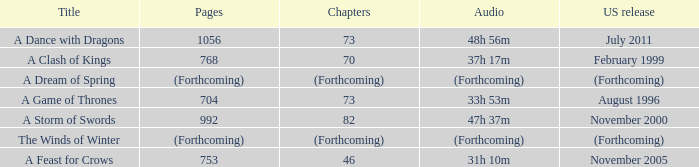Which US release has 704 pages? August 1996. 